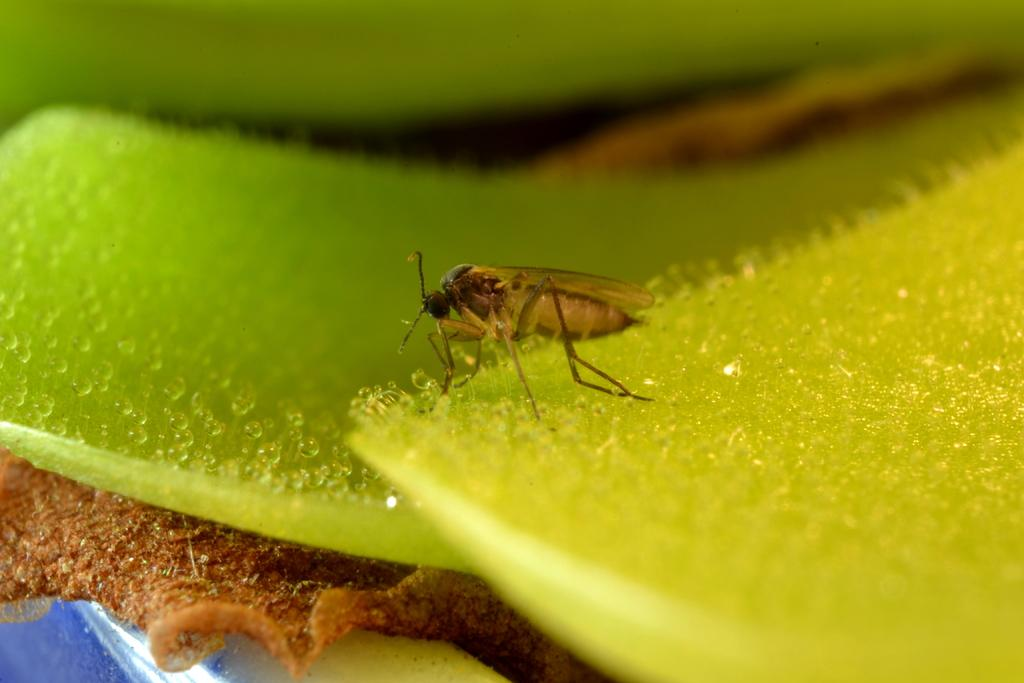What type of creature can be seen in the image? There is an insect in the image. What is the insect's location in the image? The insect is on a green surface. What type of stew is being prepared in the image? There is no stew present in the image; it only features an insect on a green surface. 